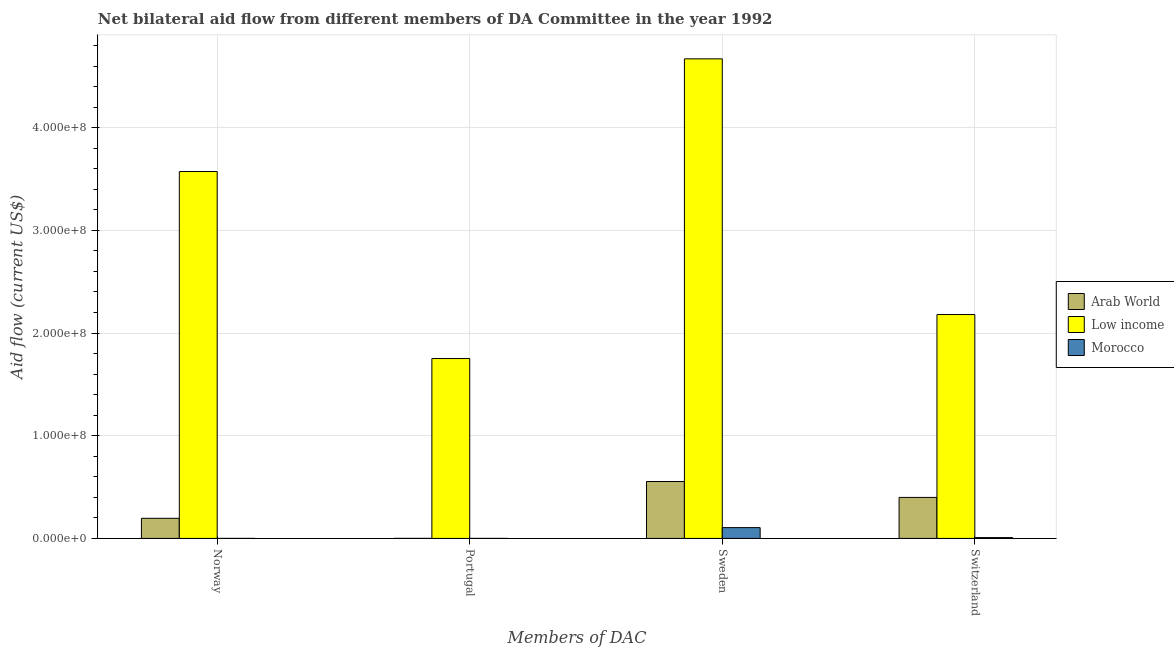How many different coloured bars are there?
Offer a very short reply. 3. Are the number of bars per tick equal to the number of legend labels?
Your answer should be compact. Yes. Are the number of bars on each tick of the X-axis equal?
Offer a terse response. Yes. What is the label of the 4th group of bars from the left?
Offer a very short reply. Switzerland. What is the amount of aid given by portugal in Morocco?
Your response must be concise. 4.00e+04. Across all countries, what is the maximum amount of aid given by sweden?
Provide a succinct answer. 4.67e+08. Across all countries, what is the minimum amount of aid given by switzerland?
Offer a very short reply. 8.20e+05. In which country was the amount of aid given by norway minimum?
Provide a succinct answer. Morocco. What is the total amount of aid given by portugal in the graph?
Offer a terse response. 1.75e+08. What is the difference between the amount of aid given by norway in Low income and that in Arab World?
Ensure brevity in your answer.  3.38e+08. What is the difference between the amount of aid given by norway in Morocco and the amount of aid given by portugal in Low income?
Ensure brevity in your answer.  -1.75e+08. What is the average amount of aid given by switzerland per country?
Give a very brief answer. 8.63e+07. What is the difference between the amount of aid given by switzerland and amount of aid given by sweden in Arab World?
Keep it short and to the point. -1.55e+07. In how many countries, is the amount of aid given by switzerland greater than 360000000 US$?
Offer a very short reply. 0. What is the ratio of the amount of aid given by switzerland in Low income to that in Morocco?
Provide a succinct answer. 265.9. What is the difference between the highest and the second highest amount of aid given by switzerland?
Ensure brevity in your answer.  1.78e+08. What is the difference between the highest and the lowest amount of aid given by switzerland?
Offer a very short reply. 2.17e+08. Is it the case that in every country, the sum of the amount of aid given by sweden and amount of aid given by switzerland is greater than the sum of amount of aid given by portugal and amount of aid given by norway?
Your answer should be very brief. No. What does the 3rd bar from the right in Sweden represents?
Keep it short and to the point. Arab World. What is the difference between two consecutive major ticks on the Y-axis?
Make the answer very short. 1.00e+08. Does the graph contain any zero values?
Offer a terse response. No. How many legend labels are there?
Your answer should be very brief. 3. How are the legend labels stacked?
Ensure brevity in your answer.  Vertical. What is the title of the graph?
Give a very brief answer. Net bilateral aid flow from different members of DA Committee in the year 1992. What is the label or title of the X-axis?
Your response must be concise. Members of DAC. What is the label or title of the Y-axis?
Offer a terse response. Aid flow (current US$). What is the Aid flow (current US$) of Arab World in Norway?
Your response must be concise. 1.96e+07. What is the Aid flow (current US$) of Low income in Norway?
Provide a short and direct response. 3.57e+08. What is the Aid flow (current US$) in Morocco in Norway?
Your answer should be compact. 3.00e+04. What is the Aid flow (current US$) in Arab World in Portugal?
Your answer should be very brief. 5.00e+04. What is the Aid flow (current US$) in Low income in Portugal?
Provide a succinct answer. 1.75e+08. What is the Aid flow (current US$) in Morocco in Portugal?
Provide a succinct answer. 4.00e+04. What is the Aid flow (current US$) of Arab World in Sweden?
Your response must be concise. 5.54e+07. What is the Aid flow (current US$) of Low income in Sweden?
Make the answer very short. 4.67e+08. What is the Aid flow (current US$) in Morocco in Sweden?
Your answer should be compact. 1.05e+07. What is the Aid flow (current US$) in Arab World in Switzerland?
Provide a succinct answer. 3.99e+07. What is the Aid flow (current US$) of Low income in Switzerland?
Keep it short and to the point. 2.18e+08. What is the Aid flow (current US$) of Morocco in Switzerland?
Make the answer very short. 8.20e+05. Across all Members of DAC, what is the maximum Aid flow (current US$) of Arab World?
Provide a short and direct response. 5.54e+07. Across all Members of DAC, what is the maximum Aid flow (current US$) in Low income?
Offer a terse response. 4.67e+08. Across all Members of DAC, what is the maximum Aid flow (current US$) in Morocco?
Make the answer very short. 1.05e+07. Across all Members of DAC, what is the minimum Aid flow (current US$) of Low income?
Provide a succinct answer. 1.75e+08. Across all Members of DAC, what is the minimum Aid flow (current US$) of Morocco?
Provide a short and direct response. 3.00e+04. What is the total Aid flow (current US$) of Arab World in the graph?
Your answer should be very brief. 1.15e+08. What is the total Aid flow (current US$) of Low income in the graph?
Make the answer very short. 1.22e+09. What is the total Aid flow (current US$) of Morocco in the graph?
Keep it short and to the point. 1.14e+07. What is the difference between the Aid flow (current US$) in Arab World in Norway and that in Portugal?
Keep it short and to the point. 1.96e+07. What is the difference between the Aid flow (current US$) of Low income in Norway and that in Portugal?
Offer a terse response. 1.82e+08. What is the difference between the Aid flow (current US$) of Arab World in Norway and that in Sweden?
Provide a succinct answer. -3.58e+07. What is the difference between the Aid flow (current US$) in Low income in Norway and that in Sweden?
Give a very brief answer. -1.10e+08. What is the difference between the Aid flow (current US$) of Morocco in Norway and that in Sweden?
Your answer should be very brief. -1.05e+07. What is the difference between the Aid flow (current US$) of Arab World in Norway and that in Switzerland?
Provide a short and direct response. -2.03e+07. What is the difference between the Aid flow (current US$) in Low income in Norway and that in Switzerland?
Offer a terse response. 1.39e+08. What is the difference between the Aid flow (current US$) in Morocco in Norway and that in Switzerland?
Give a very brief answer. -7.90e+05. What is the difference between the Aid flow (current US$) of Arab World in Portugal and that in Sweden?
Offer a very short reply. -5.54e+07. What is the difference between the Aid flow (current US$) of Low income in Portugal and that in Sweden?
Your answer should be compact. -2.92e+08. What is the difference between the Aid flow (current US$) of Morocco in Portugal and that in Sweden?
Offer a terse response. -1.05e+07. What is the difference between the Aid flow (current US$) of Arab World in Portugal and that in Switzerland?
Provide a succinct answer. -3.99e+07. What is the difference between the Aid flow (current US$) of Low income in Portugal and that in Switzerland?
Offer a terse response. -4.29e+07. What is the difference between the Aid flow (current US$) in Morocco in Portugal and that in Switzerland?
Ensure brevity in your answer.  -7.80e+05. What is the difference between the Aid flow (current US$) in Arab World in Sweden and that in Switzerland?
Provide a succinct answer. 1.55e+07. What is the difference between the Aid flow (current US$) of Low income in Sweden and that in Switzerland?
Your answer should be very brief. 2.49e+08. What is the difference between the Aid flow (current US$) of Morocco in Sweden and that in Switzerland?
Provide a short and direct response. 9.72e+06. What is the difference between the Aid flow (current US$) of Arab World in Norway and the Aid flow (current US$) of Low income in Portugal?
Give a very brief answer. -1.56e+08. What is the difference between the Aid flow (current US$) in Arab World in Norway and the Aid flow (current US$) in Morocco in Portugal?
Make the answer very short. 1.96e+07. What is the difference between the Aid flow (current US$) of Low income in Norway and the Aid flow (current US$) of Morocco in Portugal?
Your answer should be very brief. 3.57e+08. What is the difference between the Aid flow (current US$) in Arab World in Norway and the Aid flow (current US$) in Low income in Sweden?
Offer a terse response. -4.47e+08. What is the difference between the Aid flow (current US$) in Arab World in Norway and the Aid flow (current US$) in Morocco in Sweden?
Give a very brief answer. 9.07e+06. What is the difference between the Aid flow (current US$) in Low income in Norway and the Aid flow (current US$) in Morocco in Sweden?
Offer a terse response. 3.47e+08. What is the difference between the Aid flow (current US$) in Arab World in Norway and the Aid flow (current US$) in Low income in Switzerland?
Ensure brevity in your answer.  -1.98e+08. What is the difference between the Aid flow (current US$) of Arab World in Norway and the Aid flow (current US$) of Morocco in Switzerland?
Provide a short and direct response. 1.88e+07. What is the difference between the Aid flow (current US$) of Low income in Norway and the Aid flow (current US$) of Morocco in Switzerland?
Provide a short and direct response. 3.56e+08. What is the difference between the Aid flow (current US$) of Arab World in Portugal and the Aid flow (current US$) of Low income in Sweden?
Make the answer very short. -4.67e+08. What is the difference between the Aid flow (current US$) of Arab World in Portugal and the Aid flow (current US$) of Morocco in Sweden?
Your response must be concise. -1.05e+07. What is the difference between the Aid flow (current US$) in Low income in Portugal and the Aid flow (current US$) in Morocco in Sweden?
Your response must be concise. 1.65e+08. What is the difference between the Aid flow (current US$) of Arab World in Portugal and the Aid flow (current US$) of Low income in Switzerland?
Give a very brief answer. -2.18e+08. What is the difference between the Aid flow (current US$) in Arab World in Portugal and the Aid flow (current US$) in Morocco in Switzerland?
Give a very brief answer. -7.70e+05. What is the difference between the Aid flow (current US$) in Low income in Portugal and the Aid flow (current US$) in Morocco in Switzerland?
Provide a short and direct response. 1.74e+08. What is the difference between the Aid flow (current US$) of Arab World in Sweden and the Aid flow (current US$) of Low income in Switzerland?
Keep it short and to the point. -1.63e+08. What is the difference between the Aid flow (current US$) of Arab World in Sweden and the Aid flow (current US$) of Morocco in Switzerland?
Give a very brief answer. 5.46e+07. What is the difference between the Aid flow (current US$) of Low income in Sweden and the Aid flow (current US$) of Morocco in Switzerland?
Provide a short and direct response. 4.66e+08. What is the average Aid flow (current US$) of Arab World per Members of DAC?
Offer a terse response. 2.88e+07. What is the average Aid flow (current US$) in Low income per Members of DAC?
Offer a very short reply. 3.04e+08. What is the average Aid flow (current US$) in Morocco per Members of DAC?
Keep it short and to the point. 2.86e+06. What is the difference between the Aid flow (current US$) of Arab World and Aid flow (current US$) of Low income in Norway?
Give a very brief answer. -3.38e+08. What is the difference between the Aid flow (current US$) of Arab World and Aid flow (current US$) of Morocco in Norway?
Provide a succinct answer. 1.96e+07. What is the difference between the Aid flow (current US$) of Low income and Aid flow (current US$) of Morocco in Norway?
Offer a terse response. 3.57e+08. What is the difference between the Aid flow (current US$) in Arab World and Aid flow (current US$) in Low income in Portugal?
Make the answer very short. -1.75e+08. What is the difference between the Aid flow (current US$) in Low income and Aid flow (current US$) in Morocco in Portugal?
Keep it short and to the point. 1.75e+08. What is the difference between the Aid flow (current US$) of Arab World and Aid flow (current US$) of Low income in Sweden?
Provide a succinct answer. -4.12e+08. What is the difference between the Aid flow (current US$) in Arab World and Aid flow (current US$) in Morocco in Sweden?
Your answer should be compact. 4.49e+07. What is the difference between the Aid flow (current US$) in Low income and Aid flow (current US$) in Morocco in Sweden?
Your answer should be compact. 4.56e+08. What is the difference between the Aid flow (current US$) in Arab World and Aid flow (current US$) in Low income in Switzerland?
Your answer should be very brief. -1.78e+08. What is the difference between the Aid flow (current US$) in Arab World and Aid flow (current US$) in Morocco in Switzerland?
Provide a succinct answer. 3.91e+07. What is the difference between the Aid flow (current US$) of Low income and Aid flow (current US$) of Morocco in Switzerland?
Offer a very short reply. 2.17e+08. What is the ratio of the Aid flow (current US$) in Arab World in Norway to that in Portugal?
Your answer should be compact. 392.2. What is the ratio of the Aid flow (current US$) in Low income in Norway to that in Portugal?
Ensure brevity in your answer.  2.04. What is the ratio of the Aid flow (current US$) of Morocco in Norway to that in Portugal?
Keep it short and to the point. 0.75. What is the ratio of the Aid flow (current US$) of Arab World in Norway to that in Sweden?
Ensure brevity in your answer.  0.35. What is the ratio of the Aid flow (current US$) of Low income in Norway to that in Sweden?
Offer a very short reply. 0.77. What is the ratio of the Aid flow (current US$) in Morocco in Norway to that in Sweden?
Ensure brevity in your answer.  0. What is the ratio of the Aid flow (current US$) of Arab World in Norway to that in Switzerland?
Your answer should be very brief. 0.49. What is the ratio of the Aid flow (current US$) of Low income in Norway to that in Switzerland?
Keep it short and to the point. 1.64. What is the ratio of the Aid flow (current US$) of Morocco in Norway to that in Switzerland?
Your answer should be compact. 0.04. What is the ratio of the Aid flow (current US$) in Arab World in Portugal to that in Sweden?
Provide a succinct answer. 0. What is the ratio of the Aid flow (current US$) of Low income in Portugal to that in Sweden?
Your answer should be compact. 0.38. What is the ratio of the Aid flow (current US$) in Morocco in Portugal to that in Sweden?
Keep it short and to the point. 0. What is the ratio of the Aid flow (current US$) in Arab World in Portugal to that in Switzerland?
Give a very brief answer. 0. What is the ratio of the Aid flow (current US$) in Low income in Portugal to that in Switzerland?
Your response must be concise. 0.8. What is the ratio of the Aid flow (current US$) in Morocco in Portugal to that in Switzerland?
Your answer should be compact. 0.05. What is the ratio of the Aid flow (current US$) of Arab World in Sweden to that in Switzerland?
Offer a very short reply. 1.39. What is the ratio of the Aid flow (current US$) in Low income in Sweden to that in Switzerland?
Offer a very short reply. 2.14. What is the ratio of the Aid flow (current US$) in Morocco in Sweden to that in Switzerland?
Your response must be concise. 12.85. What is the difference between the highest and the second highest Aid flow (current US$) in Arab World?
Make the answer very short. 1.55e+07. What is the difference between the highest and the second highest Aid flow (current US$) in Low income?
Offer a terse response. 1.10e+08. What is the difference between the highest and the second highest Aid flow (current US$) in Morocco?
Provide a succinct answer. 9.72e+06. What is the difference between the highest and the lowest Aid flow (current US$) of Arab World?
Provide a short and direct response. 5.54e+07. What is the difference between the highest and the lowest Aid flow (current US$) in Low income?
Your answer should be very brief. 2.92e+08. What is the difference between the highest and the lowest Aid flow (current US$) of Morocco?
Offer a terse response. 1.05e+07. 